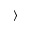<formula> <loc_0><loc_0><loc_500><loc_500>^ { \circ } \rangle</formula> 